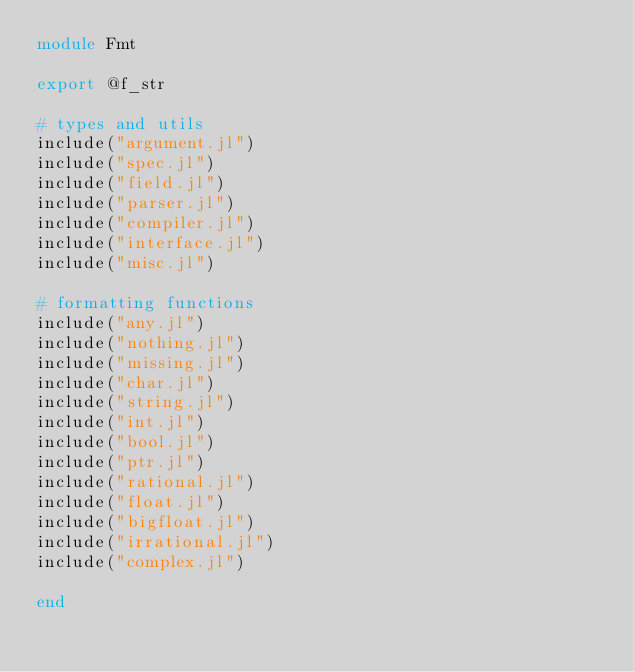<code> <loc_0><loc_0><loc_500><loc_500><_Julia_>module Fmt

export @f_str

# types and utils
include("argument.jl")
include("spec.jl")
include("field.jl")
include("parser.jl")
include("compiler.jl")
include("interface.jl")
include("misc.jl")

# formatting functions
include("any.jl")
include("nothing.jl")
include("missing.jl")
include("char.jl")
include("string.jl")
include("int.jl")
include("bool.jl")
include("ptr.jl")
include("rational.jl")
include("float.jl")
include("bigfloat.jl")
include("irrational.jl")
include("complex.jl")

end
</code> 